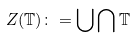<formula> <loc_0><loc_0><loc_500><loc_500>Z ( \mathbb { T } ) \colon = \bigcup \bigcap \mathbb { T }</formula> 